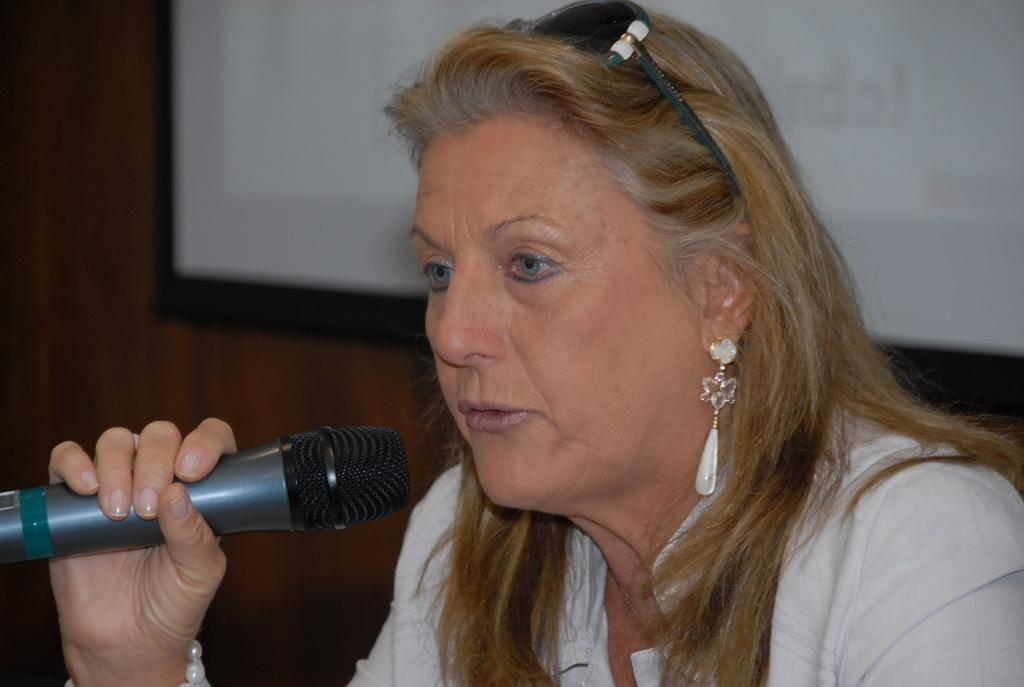Who is the main subject in the image? There is a woman in the image. What is the woman doing in the image? The woman is talking on a microphone. What can be seen in the background of the image? There is a screen and a wall in the background of the image. What type of pickle is the woman holding in the image? There is no pickle present in the image. Can you see any blood on the woman's hands in the image? There is no blood visible on the woman's hands in the image. 